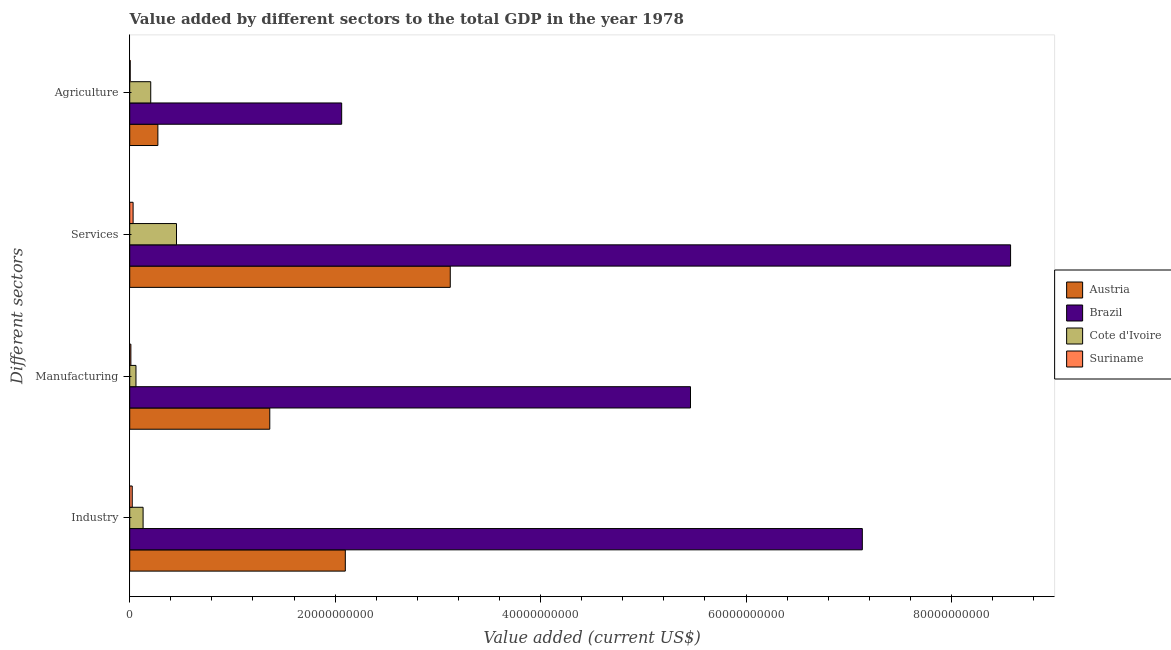How many groups of bars are there?
Provide a short and direct response. 4. Are the number of bars per tick equal to the number of legend labels?
Offer a terse response. Yes. How many bars are there on the 4th tick from the top?
Provide a succinct answer. 4. What is the label of the 4th group of bars from the top?
Your response must be concise. Industry. What is the value added by manufacturing sector in Cote d'Ivoire?
Your answer should be compact. 6.07e+08. Across all countries, what is the maximum value added by services sector?
Your answer should be very brief. 8.58e+1. Across all countries, what is the minimum value added by industrial sector?
Your answer should be very brief. 2.45e+08. In which country was the value added by services sector maximum?
Make the answer very short. Brazil. In which country was the value added by industrial sector minimum?
Provide a short and direct response. Suriname. What is the total value added by manufacturing sector in the graph?
Offer a terse response. 6.90e+1. What is the difference between the value added by agricultural sector in Suriname and that in Austria?
Ensure brevity in your answer.  -2.69e+09. What is the difference between the value added by manufacturing sector in Suriname and the value added by agricultural sector in Brazil?
Make the answer very short. -2.05e+1. What is the average value added by agricultural sector per country?
Your answer should be very brief. 6.37e+09. What is the difference between the value added by manufacturing sector and value added by agricultural sector in Brazil?
Offer a terse response. 3.40e+1. What is the ratio of the value added by manufacturing sector in Brazil to that in Austria?
Keep it short and to the point. 4. Is the value added by manufacturing sector in Brazil less than that in Suriname?
Provide a short and direct response. No. Is the difference between the value added by industrial sector in Cote d'Ivoire and Austria greater than the difference between the value added by services sector in Cote d'Ivoire and Austria?
Give a very brief answer. Yes. What is the difference between the highest and the second highest value added by manufacturing sector?
Your response must be concise. 4.10e+1. What is the difference between the highest and the lowest value added by industrial sector?
Keep it short and to the point. 7.11e+1. In how many countries, is the value added by manufacturing sector greater than the average value added by manufacturing sector taken over all countries?
Your answer should be very brief. 1. Is the sum of the value added by manufacturing sector in Brazil and Cote d'Ivoire greater than the maximum value added by industrial sector across all countries?
Offer a very short reply. No. What does the 1st bar from the top in Industry represents?
Offer a terse response. Suriname. What does the 4th bar from the bottom in Agriculture represents?
Provide a succinct answer. Suriname. Is it the case that in every country, the sum of the value added by industrial sector and value added by manufacturing sector is greater than the value added by services sector?
Provide a succinct answer. No. How many countries are there in the graph?
Offer a terse response. 4. Are the values on the major ticks of X-axis written in scientific E-notation?
Provide a succinct answer. No. Does the graph contain any zero values?
Give a very brief answer. No. How many legend labels are there?
Provide a succinct answer. 4. What is the title of the graph?
Keep it short and to the point. Value added by different sectors to the total GDP in the year 1978. Does "Libya" appear as one of the legend labels in the graph?
Keep it short and to the point. No. What is the label or title of the X-axis?
Your response must be concise. Value added (current US$). What is the label or title of the Y-axis?
Give a very brief answer. Different sectors. What is the Value added (current US$) in Austria in Industry?
Ensure brevity in your answer.  2.10e+1. What is the Value added (current US$) in Brazil in Industry?
Your answer should be very brief. 7.13e+1. What is the Value added (current US$) in Cote d'Ivoire in Industry?
Keep it short and to the point. 1.30e+09. What is the Value added (current US$) of Suriname in Industry?
Your answer should be compact. 2.45e+08. What is the Value added (current US$) in Austria in Manufacturing?
Offer a very short reply. 1.36e+1. What is the Value added (current US$) in Brazil in Manufacturing?
Provide a succinct answer. 5.46e+1. What is the Value added (current US$) in Cote d'Ivoire in Manufacturing?
Ensure brevity in your answer.  6.07e+08. What is the Value added (current US$) in Suriname in Manufacturing?
Make the answer very short. 1.13e+08. What is the Value added (current US$) in Austria in Services?
Your answer should be compact. 3.12e+1. What is the Value added (current US$) in Brazil in Services?
Your answer should be very brief. 8.58e+1. What is the Value added (current US$) in Cote d'Ivoire in Services?
Your answer should be very brief. 4.55e+09. What is the Value added (current US$) in Suriname in Services?
Your answer should be compact. 3.27e+08. What is the Value added (current US$) in Austria in Agriculture?
Your answer should be very brief. 2.74e+09. What is the Value added (current US$) of Brazil in Agriculture?
Offer a terse response. 2.06e+1. What is the Value added (current US$) in Cote d'Ivoire in Agriculture?
Provide a short and direct response. 2.04e+09. What is the Value added (current US$) of Suriname in Agriculture?
Your response must be concise. 4.58e+07. Across all Different sectors, what is the maximum Value added (current US$) of Austria?
Ensure brevity in your answer.  3.12e+1. Across all Different sectors, what is the maximum Value added (current US$) in Brazil?
Provide a short and direct response. 8.58e+1. Across all Different sectors, what is the maximum Value added (current US$) of Cote d'Ivoire?
Your response must be concise. 4.55e+09. Across all Different sectors, what is the maximum Value added (current US$) of Suriname?
Ensure brevity in your answer.  3.27e+08. Across all Different sectors, what is the minimum Value added (current US$) of Austria?
Your response must be concise. 2.74e+09. Across all Different sectors, what is the minimum Value added (current US$) of Brazil?
Give a very brief answer. 2.06e+1. Across all Different sectors, what is the minimum Value added (current US$) in Cote d'Ivoire?
Your answer should be compact. 6.07e+08. Across all Different sectors, what is the minimum Value added (current US$) in Suriname?
Your response must be concise. 4.58e+07. What is the total Value added (current US$) in Austria in the graph?
Offer a terse response. 6.86e+1. What is the total Value added (current US$) in Brazil in the graph?
Your response must be concise. 2.32e+11. What is the total Value added (current US$) of Cote d'Ivoire in the graph?
Your response must be concise. 8.51e+09. What is the total Value added (current US$) of Suriname in the graph?
Provide a succinct answer. 7.31e+08. What is the difference between the Value added (current US$) of Austria in Industry and that in Manufacturing?
Provide a short and direct response. 7.35e+09. What is the difference between the Value added (current US$) in Brazil in Industry and that in Manufacturing?
Provide a succinct answer. 1.67e+1. What is the difference between the Value added (current US$) of Cote d'Ivoire in Industry and that in Manufacturing?
Give a very brief answer. 6.95e+08. What is the difference between the Value added (current US$) of Suriname in Industry and that in Manufacturing?
Your answer should be very brief. 1.32e+08. What is the difference between the Value added (current US$) in Austria in Industry and that in Services?
Offer a terse response. -1.02e+1. What is the difference between the Value added (current US$) in Brazil in Industry and that in Services?
Your answer should be compact. -1.44e+1. What is the difference between the Value added (current US$) in Cote d'Ivoire in Industry and that in Services?
Your response must be concise. -3.25e+09. What is the difference between the Value added (current US$) of Suriname in Industry and that in Services?
Your answer should be very brief. -8.26e+07. What is the difference between the Value added (current US$) of Austria in Industry and that in Agriculture?
Offer a terse response. 1.82e+1. What is the difference between the Value added (current US$) in Brazil in Industry and that in Agriculture?
Make the answer very short. 5.07e+1. What is the difference between the Value added (current US$) of Cote d'Ivoire in Industry and that in Agriculture?
Offer a terse response. -7.43e+08. What is the difference between the Value added (current US$) of Suriname in Industry and that in Agriculture?
Your answer should be compact. 1.99e+08. What is the difference between the Value added (current US$) of Austria in Manufacturing and that in Services?
Provide a succinct answer. -1.76e+1. What is the difference between the Value added (current US$) of Brazil in Manufacturing and that in Services?
Keep it short and to the point. -3.12e+1. What is the difference between the Value added (current US$) in Cote d'Ivoire in Manufacturing and that in Services?
Ensure brevity in your answer.  -3.95e+09. What is the difference between the Value added (current US$) of Suriname in Manufacturing and that in Services?
Ensure brevity in your answer.  -2.15e+08. What is the difference between the Value added (current US$) in Austria in Manufacturing and that in Agriculture?
Provide a short and direct response. 1.09e+1. What is the difference between the Value added (current US$) of Brazil in Manufacturing and that in Agriculture?
Offer a very short reply. 3.40e+1. What is the difference between the Value added (current US$) of Cote d'Ivoire in Manufacturing and that in Agriculture?
Provide a succinct answer. -1.44e+09. What is the difference between the Value added (current US$) in Suriname in Manufacturing and that in Agriculture?
Make the answer very short. 6.68e+07. What is the difference between the Value added (current US$) in Austria in Services and that in Agriculture?
Your answer should be compact. 2.85e+1. What is the difference between the Value added (current US$) in Brazil in Services and that in Agriculture?
Your answer should be very brief. 6.51e+1. What is the difference between the Value added (current US$) of Cote d'Ivoire in Services and that in Agriculture?
Make the answer very short. 2.51e+09. What is the difference between the Value added (current US$) of Suriname in Services and that in Agriculture?
Your answer should be very brief. 2.82e+08. What is the difference between the Value added (current US$) in Austria in Industry and the Value added (current US$) in Brazil in Manufacturing?
Give a very brief answer. -3.36e+1. What is the difference between the Value added (current US$) in Austria in Industry and the Value added (current US$) in Cote d'Ivoire in Manufacturing?
Offer a terse response. 2.04e+1. What is the difference between the Value added (current US$) of Austria in Industry and the Value added (current US$) of Suriname in Manufacturing?
Offer a very short reply. 2.09e+1. What is the difference between the Value added (current US$) in Brazil in Industry and the Value added (current US$) in Cote d'Ivoire in Manufacturing?
Provide a short and direct response. 7.07e+1. What is the difference between the Value added (current US$) of Brazil in Industry and the Value added (current US$) of Suriname in Manufacturing?
Give a very brief answer. 7.12e+1. What is the difference between the Value added (current US$) of Cote d'Ivoire in Industry and the Value added (current US$) of Suriname in Manufacturing?
Offer a terse response. 1.19e+09. What is the difference between the Value added (current US$) in Austria in Industry and the Value added (current US$) in Brazil in Services?
Keep it short and to the point. -6.48e+1. What is the difference between the Value added (current US$) in Austria in Industry and the Value added (current US$) in Cote d'Ivoire in Services?
Keep it short and to the point. 1.64e+1. What is the difference between the Value added (current US$) of Austria in Industry and the Value added (current US$) of Suriname in Services?
Your answer should be very brief. 2.07e+1. What is the difference between the Value added (current US$) of Brazil in Industry and the Value added (current US$) of Cote d'Ivoire in Services?
Your answer should be very brief. 6.68e+1. What is the difference between the Value added (current US$) in Brazil in Industry and the Value added (current US$) in Suriname in Services?
Make the answer very short. 7.10e+1. What is the difference between the Value added (current US$) in Cote d'Ivoire in Industry and the Value added (current US$) in Suriname in Services?
Offer a very short reply. 9.75e+08. What is the difference between the Value added (current US$) of Austria in Industry and the Value added (current US$) of Brazil in Agriculture?
Your response must be concise. 3.53e+08. What is the difference between the Value added (current US$) of Austria in Industry and the Value added (current US$) of Cote d'Ivoire in Agriculture?
Give a very brief answer. 1.89e+1. What is the difference between the Value added (current US$) of Austria in Industry and the Value added (current US$) of Suriname in Agriculture?
Keep it short and to the point. 2.09e+1. What is the difference between the Value added (current US$) in Brazil in Industry and the Value added (current US$) in Cote d'Ivoire in Agriculture?
Your response must be concise. 6.93e+1. What is the difference between the Value added (current US$) of Brazil in Industry and the Value added (current US$) of Suriname in Agriculture?
Give a very brief answer. 7.13e+1. What is the difference between the Value added (current US$) in Cote d'Ivoire in Industry and the Value added (current US$) in Suriname in Agriculture?
Ensure brevity in your answer.  1.26e+09. What is the difference between the Value added (current US$) in Austria in Manufacturing and the Value added (current US$) in Brazil in Services?
Provide a succinct answer. -7.21e+1. What is the difference between the Value added (current US$) in Austria in Manufacturing and the Value added (current US$) in Cote d'Ivoire in Services?
Offer a terse response. 9.08e+09. What is the difference between the Value added (current US$) in Austria in Manufacturing and the Value added (current US$) in Suriname in Services?
Offer a very short reply. 1.33e+1. What is the difference between the Value added (current US$) in Brazil in Manufacturing and the Value added (current US$) in Cote d'Ivoire in Services?
Ensure brevity in your answer.  5.00e+1. What is the difference between the Value added (current US$) of Brazil in Manufacturing and the Value added (current US$) of Suriname in Services?
Ensure brevity in your answer.  5.43e+1. What is the difference between the Value added (current US$) of Cote d'Ivoire in Manufacturing and the Value added (current US$) of Suriname in Services?
Provide a succinct answer. 2.80e+08. What is the difference between the Value added (current US$) of Austria in Manufacturing and the Value added (current US$) of Brazil in Agriculture?
Your answer should be compact. -7.00e+09. What is the difference between the Value added (current US$) of Austria in Manufacturing and the Value added (current US$) of Cote d'Ivoire in Agriculture?
Your answer should be compact. 1.16e+1. What is the difference between the Value added (current US$) in Austria in Manufacturing and the Value added (current US$) in Suriname in Agriculture?
Offer a terse response. 1.36e+1. What is the difference between the Value added (current US$) of Brazil in Manufacturing and the Value added (current US$) of Cote d'Ivoire in Agriculture?
Your answer should be very brief. 5.26e+1. What is the difference between the Value added (current US$) in Brazil in Manufacturing and the Value added (current US$) in Suriname in Agriculture?
Offer a terse response. 5.46e+1. What is the difference between the Value added (current US$) of Cote d'Ivoire in Manufacturing and the Value added (current US$) of Suriname in Agriculture?
Give a very brief answer. 5.61e+08. What is the difference between the Value added (current US$) in Austria in Services and the Value added (current US$) in Brazil in Agriculture?
Provide a succinct answer. 1.06e+1. What is the difference between the Value added (current US$) in Austria in Services and the Value added (current US$) in Cote d'Ivoire in Agriculture?
Ensure brevity in your answer.  2.92e+1. What is the difference between the Value added (current US$) of Austria in Services and the Value added (current US$) of Suriname in Agriculture?
Your answer should be compact. 3.12e+1. What is the difference between the Value added (current US$) in Brazil in Services and the Value added (current US$) in Cote d'Ivoire in Agriculture?
Your response must be concise. 8.37e+1. What is the difference between the Value added (current US$) in Brazil in Services and the Value added (current US$) in Suriname in Agriculture?
Keep it short and to the point. 8.57e+1. What is the difference between the Value added (current US$) in Cote d'Ivoire in Services and the Value added (current US$) in Suriname in Agriculture?
Offer a terse response. 4.51e+09. What is the average Value added (current US$) of Austria per Different sectors?
Ensure brevity in your answer.  1.71e+1. What is the average Value added (current US$) in Brazil per Different sectors?
Make the answer very short. 5.81e+1. What is the average Value added (current US$) of Cote d'Ivoire per Different sectors?
Provide a short and direct response. 2.13e+09. What is the average Value added (current US$) in Suriname per Different sectors?
Provide a short and direct response. 1.83e+08. What is the difference between the Value added (current US$) of Austria and Value added (current US$) of Brazil in Industry?
Ensure brevity in your answer.  -5.03e+1. What is the difference between the Value added (current US$) in Austria and Value added (current US$) in Cote d'Ivoire in Industry?
Provide a succinct answer. 1.97e+1. What is the difference between the Value added (current US$) of Austria and Value added (current US$) of Suriname in Industry?
Ensure brevity in your answer.  2.07e+1. What is the difference between the Value added (current US$) in Brazil and Value added (current US$) in Cote d'Ivoire in Industry?
Provide a short and direct response. 7.00e+1. What is the difference between the Value added (current US$) in Brazil and Value added (current US$) in Suriname in Industry?
Make the answer very short. 7.11e+1. What is the difference between the Value added (current US$) of Cote d'Ivoire and Value added (current US$) of Suriname in Industry?
Your answer should be very brief. 1.06e+09. What is the difference between the Value added (current US$) of Austria and Value added (current US$) of Brazil in Manufacturing?
Your answer should be compact. -4.10e+1. What is the difference between the Value added (current US$) of Austria and Value added (current US$) of Cote d'Ivoire in Manufacturing?
Provide a succinct answer. 1.30e+1. What is the difference between the Value added (current US$) of Austria and Value added (current US$) of Suriname in Manufacturing?
Your response must be concise. 1.35e+1. What is the difference between the Value added (current US$) of Brazil and Value added (current US$) of Cote d'Ivoire in Manufacturing?
Offer a terse response. 5.40e+1. What is the difference between the Value added (current US$) in Brazil and Value added (current US$) in Suriname in Manufacturing?
Offer a very short reply. 5.45e+1. What is the difference between the Value added (current US$) of Cote d'Ivoire and Value added (current US$) of Suriname in Manufacturing?
Make the answer very short. 4.94e+08. What is the difference between the Value added (current US$) in Austria and Value added (current US$) in Brazil in Services?
Offer a very short reply. -5.46e+1. What is the difference between the Value added (current US$) of Austria and Value added (current US$) of Cote d'Ivoire in Services?
Your answer should be very brief. 2.67e+1. What is the difference between the Value added (current US$) in Austria and Value added (current US$) in Suriname in Services?
Keep it short and to the point. 3.09e+1. What is the difference between the Value added (current US$) in Brazil and Value added (current US$) in Cote d'Ivoire in Services?
Give a very brief answer. 8.12e+1. What is the difference between the Value added (current US$) of Brazil and Value added (current US$) of Suriname in Services?
Your response must be concise. 8.54e+1. What is the difference between the Value added (current US$) of Cote d'Ivoire and Value added (current US$) of Suriname in Services?
Make the answer very short. 4.23e+09. What is the difference between the Value added (current US$) of Austria and Value added (current US$) of Brazil in Agriculture?
Provide a succinct answer. -1.79e+1. What is the difference between the Value added (current US$) of Austria and Value added (current US$) of Cote d'Ivoire in Agriculture?
Offer a very short reply. 6.96e+08. What is the difference between the Value added (current US$) in Austria and Value added (current US$) in Suriname in Agriculture?
Your answer should be compact. 2.69e+09. What is the difference between the Value added (current US$) in Brazil and Value added (current US$) in Cote d'Ivoire in Agriculture?
Your answer should be very brief. 1.86e+1. What is the difference between the Value added (current US$) of Brazil and Value added (current US$) of Suriname in Agriculture?
Ensure brevity in your answer.  2.06e+1. What is the difference between the Value added (current US$) in Cote d'Ivoire and Value added (current US$) in Suriname in Agriculture?
Keep it short and to the point. 2.00e+09. What is the ratio of the Value added (current US$) of Austria in Industry to that in Manufacturing?
Your response must be concise. 1.54. What is the ratio of the Value added (current US$) of Brazil in Industry to that in Manufacturing?
Give a very brief answer. 1.31. What is the ratio of the Value added (current US$) in Cote d'Ivoire in Industry to that in Manufacturing?
Give a very brief answer. 2.14. What is the ratio of the Value added (current US$) in Suriname in Industry to that in Manufacturing?
Make the answer very short. 2.17. What is the ratio of the Value added (current US$) of Austria in Industry to that in Services?
Your answer should be compact. 0.67. What is the ratio of the Value added (current US$) in Brazil in Industry to that in Services?
Your answer should be very brief. 0.83. What is the ratio of the Value added (current US$) of Cote d'Ivoire in Industry to that in Services?
Make the answer very short. 0.29. What is the ratio of the Value added (current US$) in Suriname in Industry to that in Services?
Your answer should be compact. 0.75. What is the ratio of the Value added (current US$) of Austria in Industry to that in Agriculture?
Ensure brevity in your answer.  7.66. What is the ratio of the Value added (current US$) of Brazil in Industry to that in Agriculture?
Keep it short and to the point. 3.46. What is the ratio of the Value added (current US$) in Cote d'Ivoire in Industry to that in Agriculture?
Make the answer very short. 0.64. What is the ratio of the Value added (current US$) of Suriname in Industry to that in Agriculture?
Make the answer very short. 5.34. What is the ratio of the Value added (current US$) of Austria in Manufacturing to that in Services?
Provide a short and direct response. 0.44. What is the ratio of the Value added (current US$) in Brazil in Manufacturing to that in Services?
Make the answer very short. 0.64. What is the ratio of the Value added (current US$) of Cote d'Ivoire in Manufacturing to that in Services?
Provide a succinct answer. 0.13. What is the ratio of the Value added (current US$) of Suriname in Manufacturing to that in Services?
Your answer should be compact. 0.34. What is the ratio of the Value added (current US$) of Austria in Manufacturing to that in Agriculture?
Offer a very short reply. 4.98. What is the ratio of the Value added (current US$) of Brazil in Manufacturing to that in Agriculture?
Your response must be concise. 2.65. What is the ratio of the Value added (current US$) in Cote d'Ivoire in Manufacturing to that in Agriculture?
Your answer should be compact. 0.3. What is the ratio of the Value added (current US$) of Suriname in Manufacturing to that in Agriculture?
Give a very brief answer. 2.46. What is the ratio of the Value added (current US$) of Austria in Services to that in Agriculture?
Offer a very short reply. 11.39. What is the ratio of the Value added (current US$) of Brazil in Services to that in Agriculture?
Your answer should be compact. 4.16. What is the ratio of the Value added (current US$) of Cote d'Ivoire in Services to that in Agriculture?
Your answer should be very brief. 2.23. What is the ratio of the Value added (current US$) of Suriname in Services to that in Agriculture?
Your response must be concise. 7.14. What is the difference between the highest and the second highest Value added (current US$) in Austria?
Offer a very short reply. 1.02e+1. What is the difference between the highest and the second highest Value added (current US$) of Brazil?
Your answer should be compact. 1.44e+1. What is the difference between the highest and the second highest Value added (current US$) of Cote d'Ivoire?
Give a very brief answer. 2.51e+09. What is the difference between the highest and the second highest Value added (current US$) in Suriname?
Offer a very short reply. 8.26e+07. What is the difference between the highest and the lowest Value added (current US$) of Austria?
Make the answer very short. 2.85e+1. What is the difference between the highest and the lowest Value added (current US$) in Brazil?
Give a very brief answer. 6.51e+1. What is the difference between the highest and the lowest Value added (current US$) of Cote d'Ivoire?
Give a very brief answer. 3.95e+09. What is the difference between the highest and the lowest Value added (current US$) of Suriname?
Give a very brief answer. 2.82e+08. 